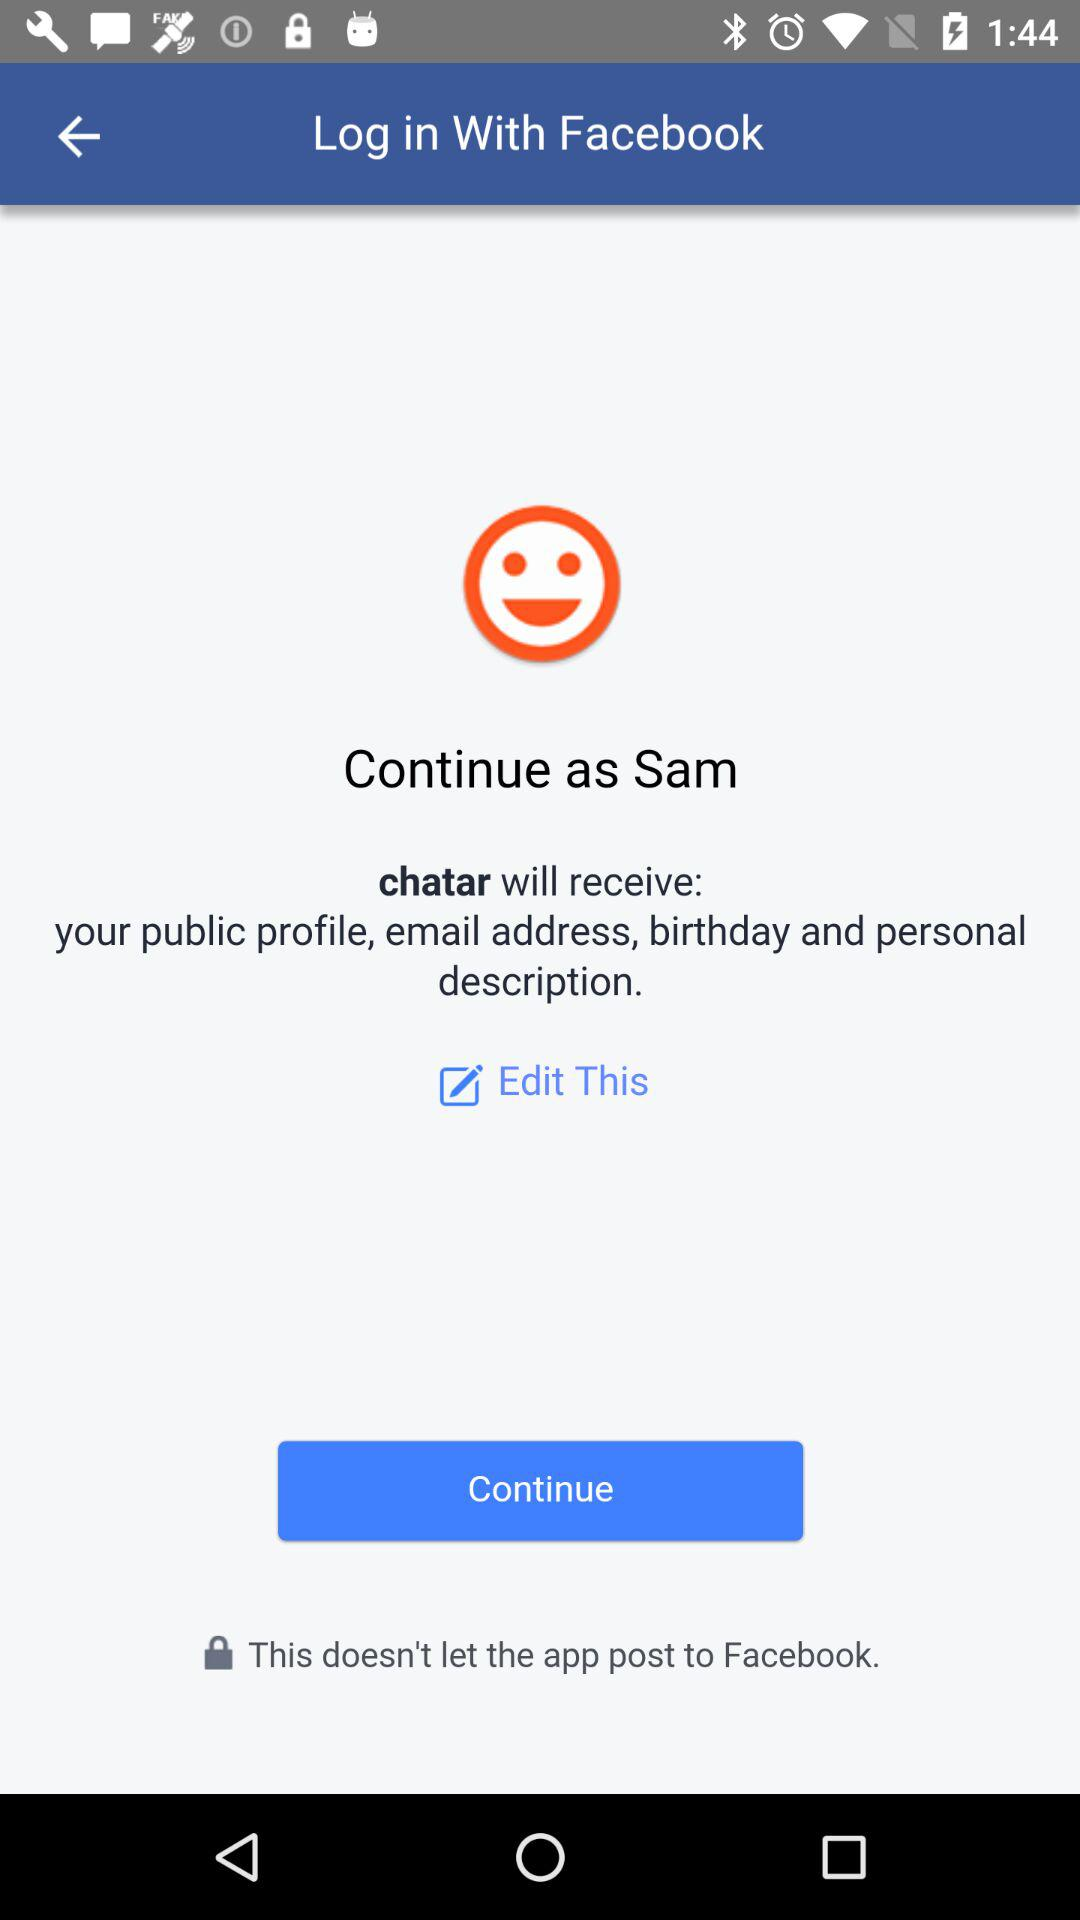What application is being used? The application "chatar" is being used. 